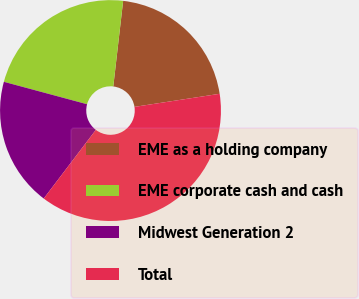Convert chart to OTSL. <chart><loc_0><loc_0><loc_500><loc_500><pie_chart><fcel>EME as a holding company<fcel>EME corporate cash and cash<fcel>Midwest Generation 2<fcel>Total<nl><fcel>20.75%<fcel>22.64%<fcel>18.86%<fcel>37.76%<nl></chart> 